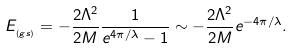<formula> <loc_0><loc_0><loc_500><loc_500>E _ { _ { ( g s ) } } = - \frac { { 2 } \Lambda ^ { 2 } } { 2 M } \frac { 1 } { e ^ { 4 \pi / \lambda } - 1 } \sim - \frac { { 2 } \Lambda ^ { 2 } } { 2 M } e ^ { - 4 \pi / \lambda } .</formula> 